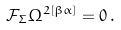Convert formula to latex. <formula><loc_0><loc_0><loc_500><loc_500>\mathcal { F } _ { \Sigma } \Omega ^ { 2 [ \beta \alpha ] } = 0 \, .</formula> 